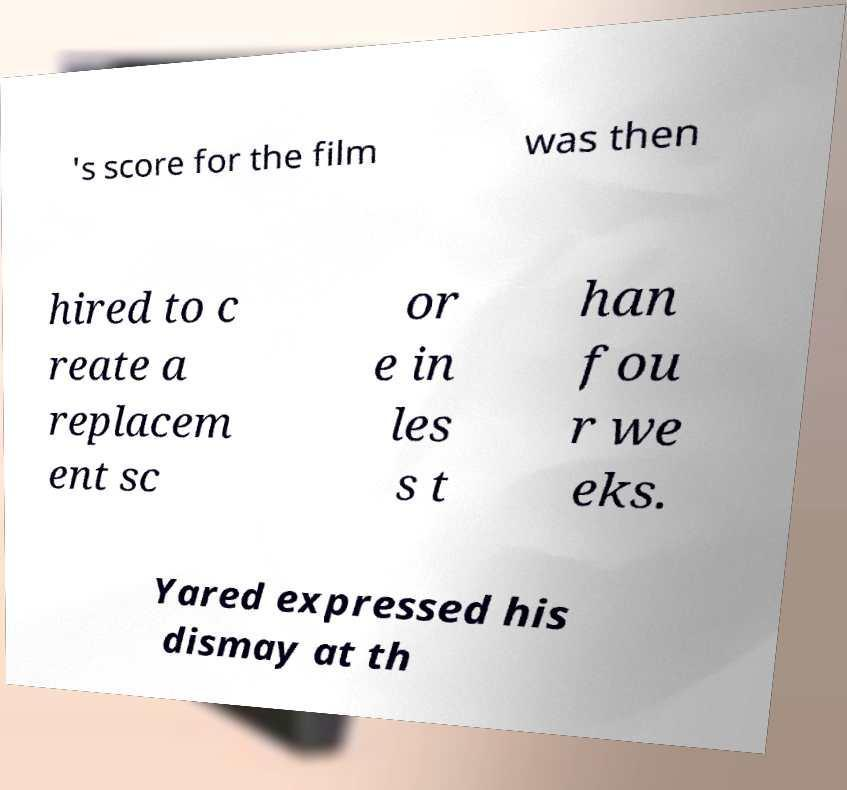For documentation purposes, I need the text within this image transcribed. Could you provide that? 's score for the film was then hired to c reate a replacem ent sc or e in les s t han fou r we eks. Yared expressed his dismay at th 